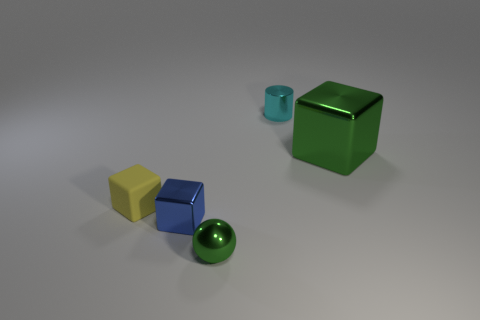Subtract all small cubes. How many cubes are left? 1 Add 1 gray metallic blocks. How many objects exist? 6 Subtract all balls. How many objects are left? 4 Add 3 big green metal things. How many big green metal things are left? 4 Add 2 matte cubes. How many matte cubes exist? 3 Subtract 0 purple cylinders. How many objects are left? 5 Subtract all gray blocks. Subtract all green cylinders. How many blocks are left? 3 Subtract all small yellow cylinders. Subtract all small cubes. How many objects are left? 3 